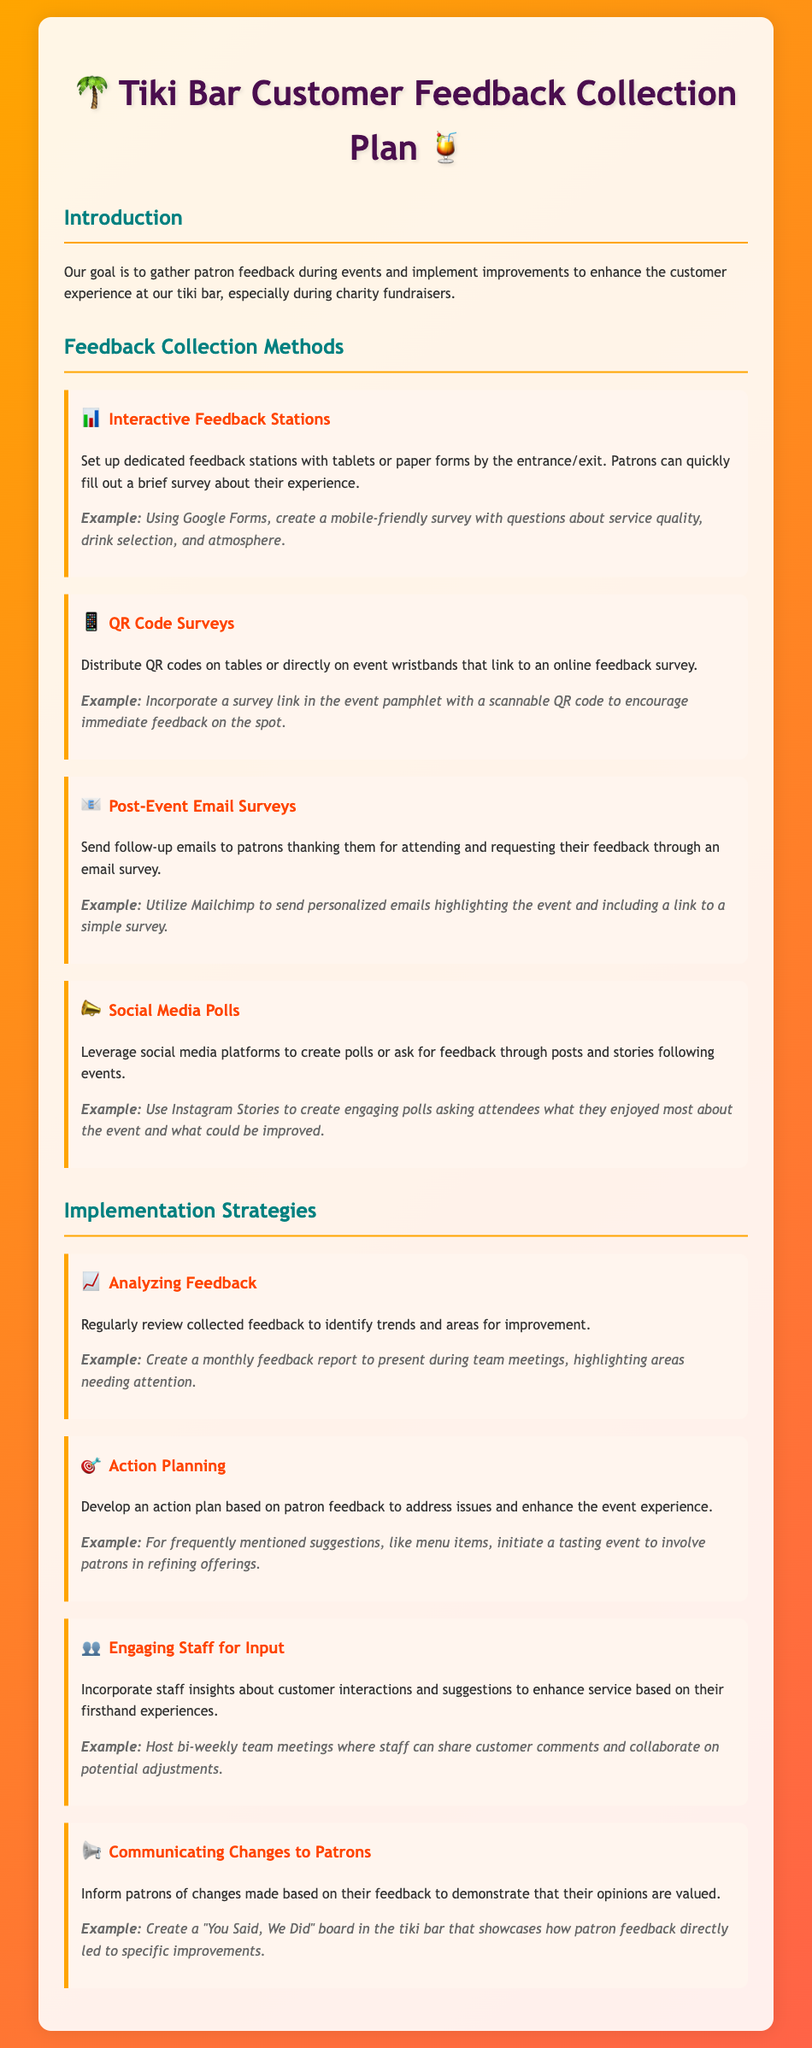What is the title of the document? The title is the main heading of the document, which summarizes the content regarding customer feedback collection at the tiki bar.
Answer: Tiki Bar Customer Feedback Collection Plan What emoji is used in the title? The title includes an emoji that adds a thematic touch to the document.
Answer: 🌴 How many feedback collection methods are listed? The number of methods can be found by counting the sections under the "Feedback Collection Methods" heading.
Answer: Four What platform is suggested for sending post-event email surveys? The document mentions a specific platform that can be used to send personalized emails to patrons.
Answer: Mailchimp What is one strategy for communicating changes to patrons? The document includes a specific method for informing patrons about improvements made based on their feedback.
Answer: "You Said, We Did" board What feedback method involves using a QR code? The method that incorporates a QR code to gather feedback is specifically identified in the document.
Answer: QR Code Surveys What is one example of an interactive feedback station? An example of a method for gathering feedback using electronic or paper formats is provided in the text.
Answer: Tablets or paper forms How often should feedback be reviewed according to the implementation strategy? The document indicates a suggested frequency for reviewing collected feedback to analyze trends.
Answer: Monthly 